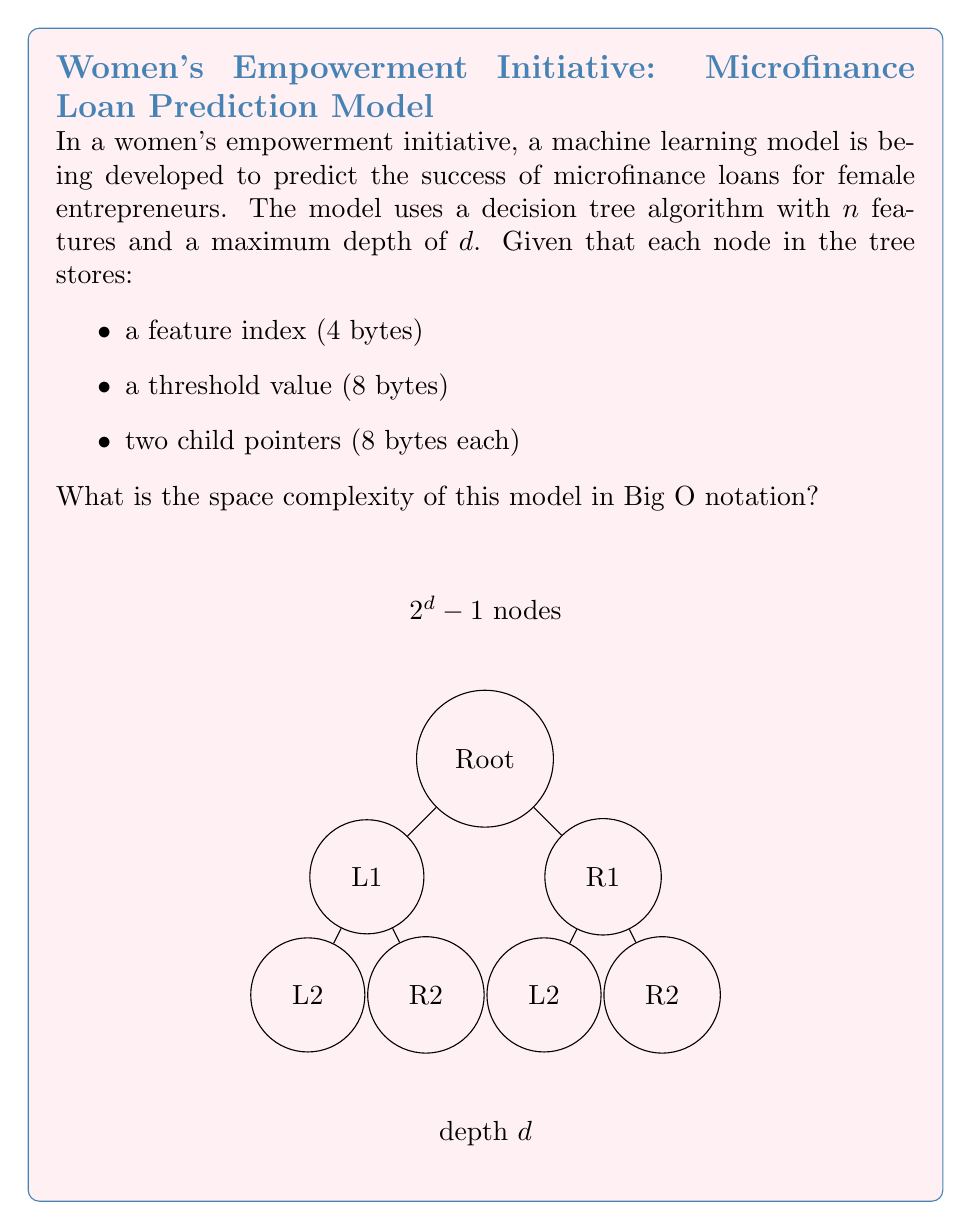Could you help me with this problem? To determine the space complexity of this decision tree model, we need to follow these steps:

1) First, let's calculate the space required for each node:
   - Feature index: 4 bytes
   - Threshold value: 8 bytes
   - Two child pointers: 2 * 8 = 16 bytes
   Total per node: 4 + 8 + 16 = 28 bytes

2) Now, we need to determine the maximum number of nodes in the tree:
   - In a binary tree with maximum depth $d$, the maximum number of nodes is $2^d - 1$
   
3) Therefore, the total space required is:
   $$ \text{Total Space} = 28 \cdot (2^d - 1) \text{ bytes} $$

4) In Big O notation, we're interested in the dominant term as $d$ grows large:
   $$ O(28 \cdot 2^d) = O(2^d) $$

5) The number of features $n$ doesn't appear in our final expression because it only affects the content of each node, not the number of nodes.

Therefore, the space complexity of this decision tree model is $O(2^d)$, where $d$ is the maximum depth of the tree.
Answer: $O(2^d)$ 